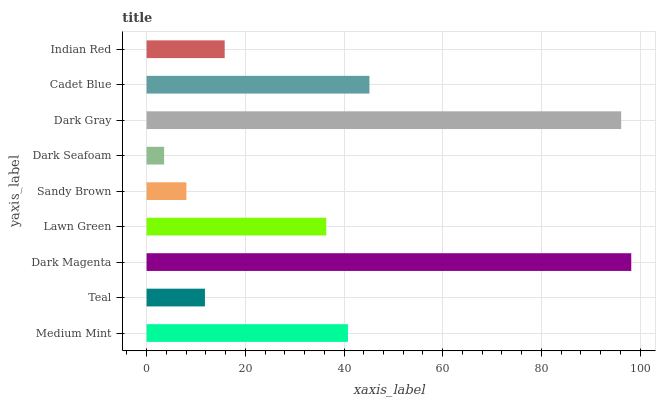Is Dark Seafoam the minimum?
Answer yes or no. Yes. Is Dark Magenta the maximum?
Answer yes or no. Yes. Is Teal the minimum?
Answer yes or no. No. Is Teal the maximum?
Answer yes or no. No. Is Medium Mint greater than Teal?
Answer yes or no. Yes. Is Teal less than Medium Mint?
Answer yes or no. Yes. Is Teal greater than Medium Mint?
Answer yes or no. No. Is Medium Mint less than Teal?
Answer yes or no. No. Is Lawn Green the high median?
Answer yes or no. Yes. Is Lawn Green the low median?
Answer yes or no. Yes. Is Dark Seafoam the high median?
Answer yes or no. No. Is Dark Magenta the low median?
Answer yes or no. No. 